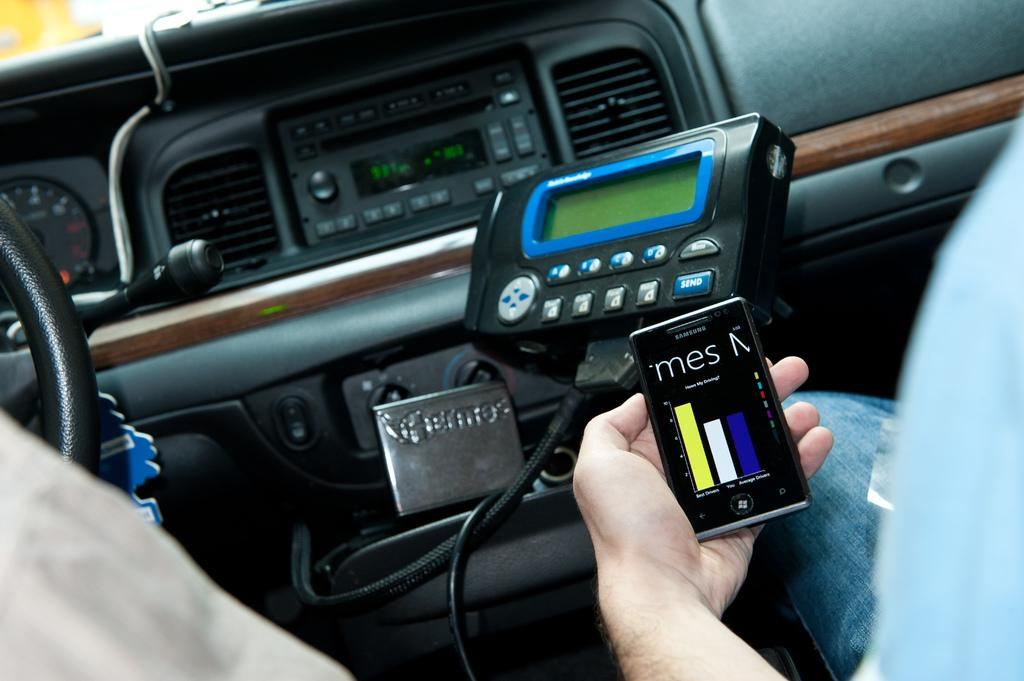What type of setting is depicted in the image? The image shows an inside view of a vehicle. What is the person in the image doing? The person is holding a mobile phone in the image. Where is the steering wheel located in the image? The steering wheel is on the left side of the image. What color is the ink spilled on the grass in the image? There is no ink or grass present in the image; it shows an inside view of a vehicle with a person holding a mobile phone and a steering wheel on the left side. 